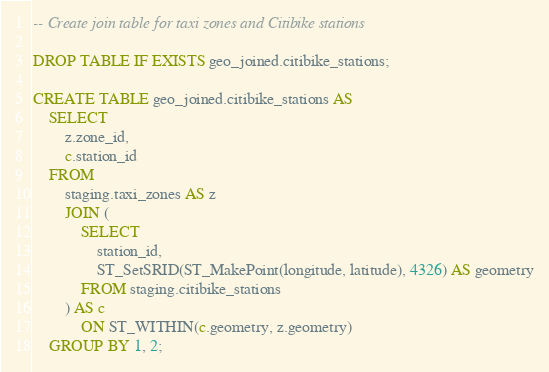<code> <loc_0><loc_0><loc_500><loc_500><_SQL_>-- Create join table for taxi zones and Citibike stations

DROP TABLE IF EXISTS geo_joined.citibike_stations;

CREATE TABLE geo_joined.citibike_stations AS
	SELECT
		z.zone_id,
		c.station_id
	FROM
		staging.taxi_zones AS z
		JOIN (
			SELECT
				station_id,
				ST_SetSRID(ST_MakePoint(longitude, latitude), 4326) AS geometry
			FROM staging.citibike_stations
		) AS c
			ON ST_WITHIN(c.geometry, z.geometry)
	GROUP BY 1, 2;
</code> 